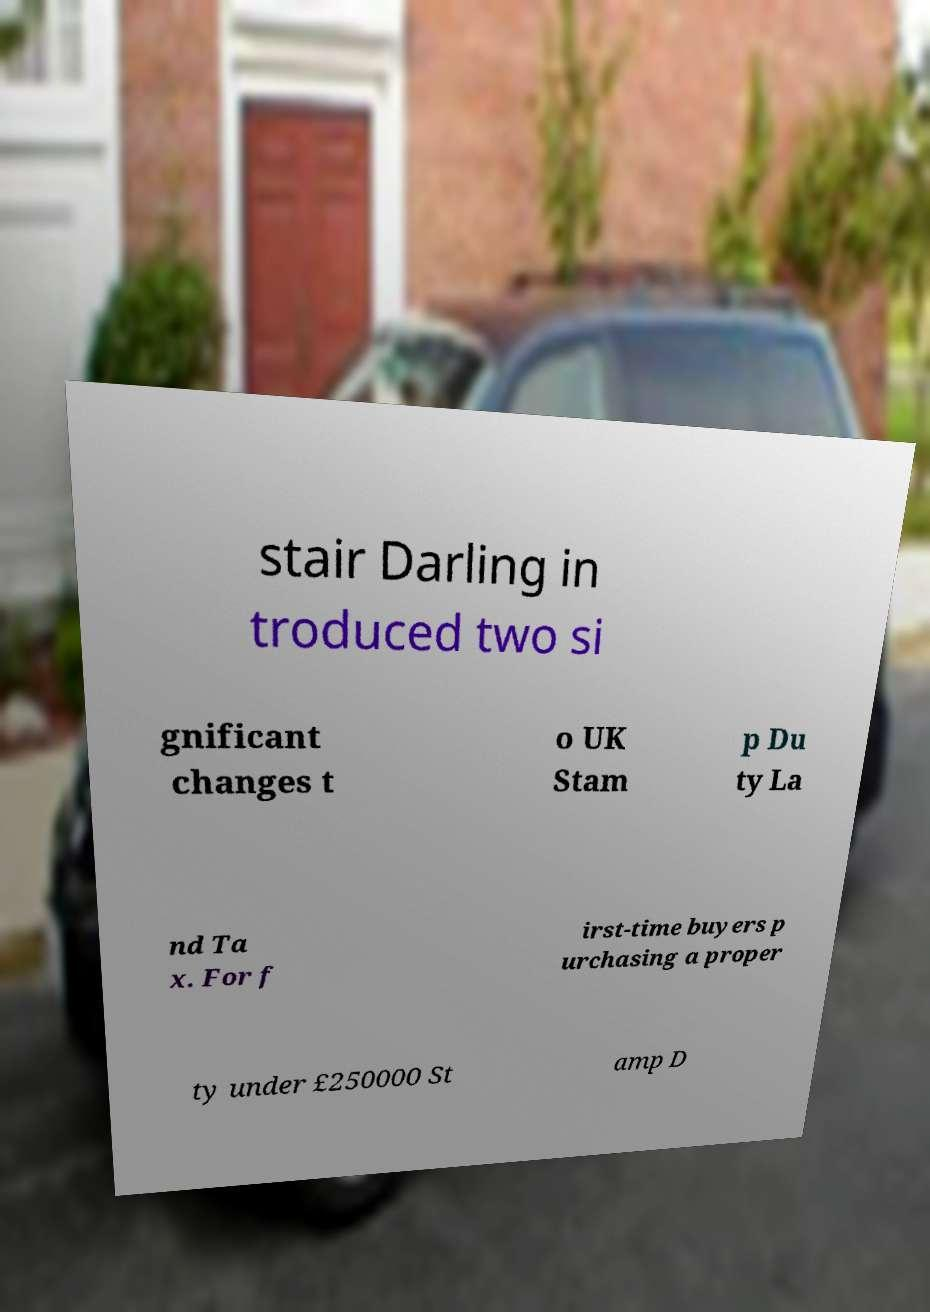Please read and relay the text visible in this image. What does it say? stair Darling in troduced two si gnificant changes t o UK Stam p Du ty La nd Ta x. For f irst-time buyers p urchasing a proper ty under £250000 St amp D 